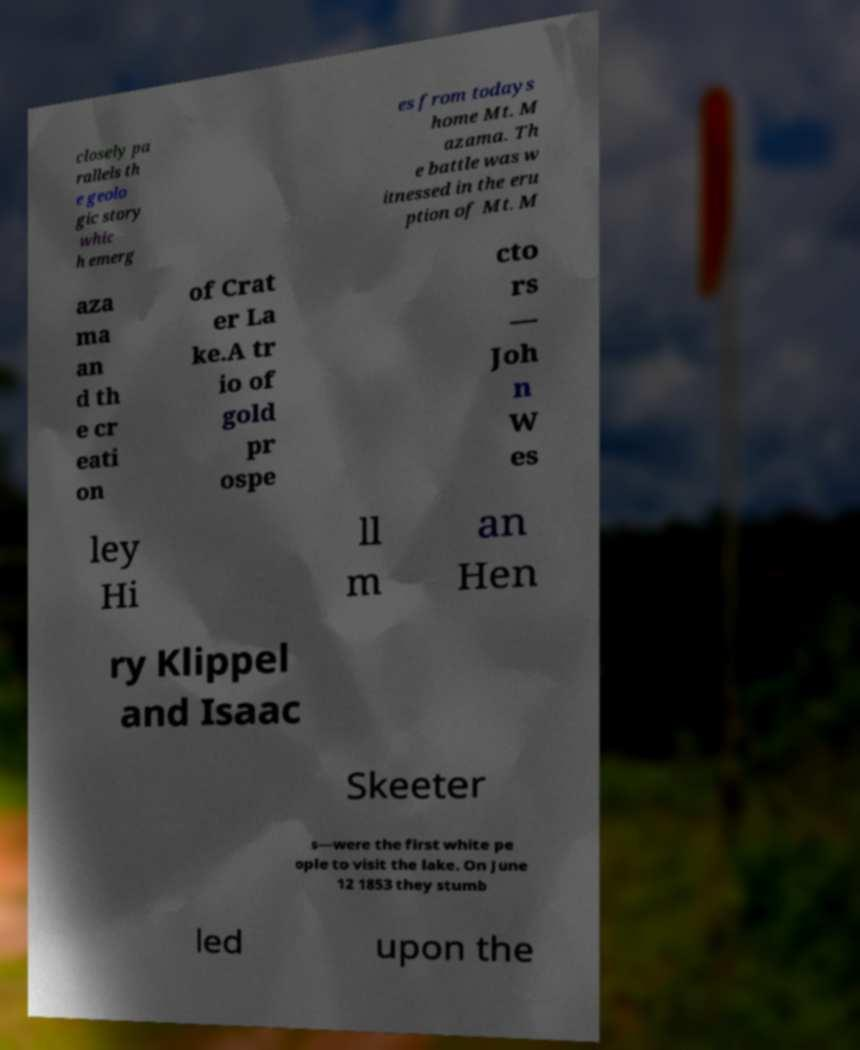Please read and relay the text visible in this image. What does it say? closely pa rallels th e geolo gic story whic h emerg es from todays home Mt. M azama. Th e battle was w itnessed in the eru ption of Mt. M aza ma an d th e cr eati on of Crat er La ke.A tr io of gold pr ospe cto rs — Joh n W es ley Hi ll m an Hen ry Klippel and Isaac Skeeter s—were the first white pe ople to visit the lake. On June 12 1853 they stumb led upon the 